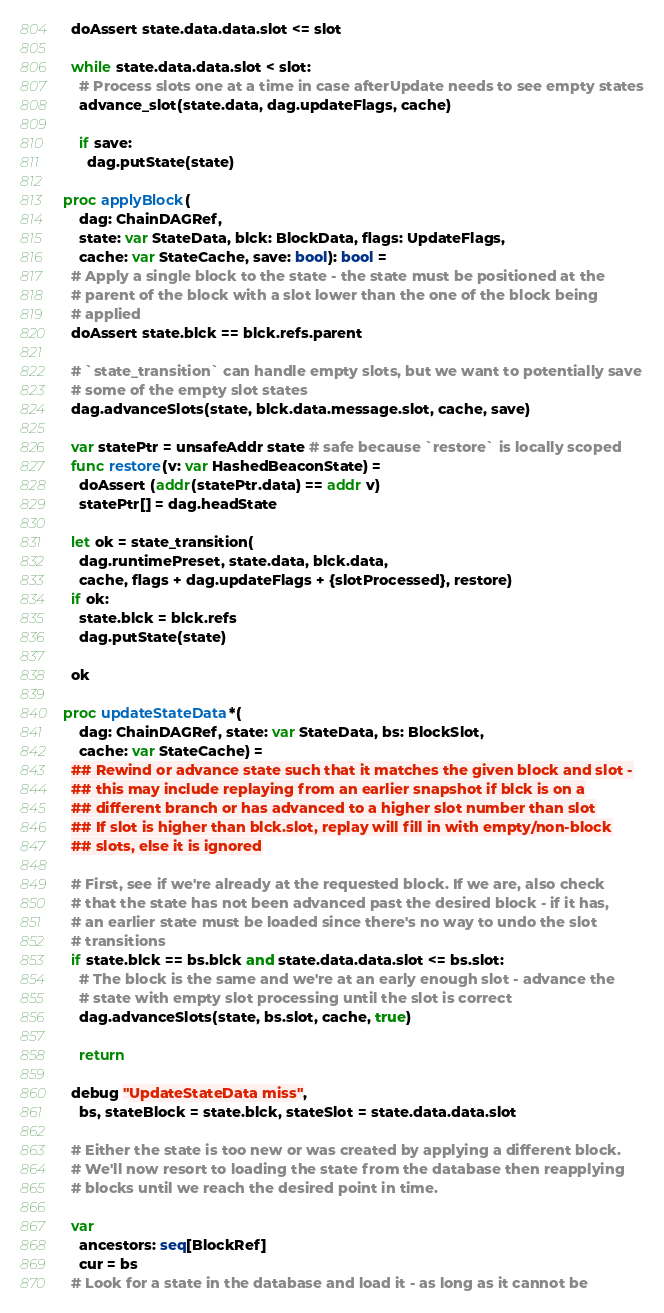<code> <loc_0><loc_0><loc_500><loc_500><_Nim_>  doAssert state.data.data.slot <= slot

  while state.data.data.slot < slot:
    # Process slots one at a time in case afterUpdate needs to see empty states
    advance_slot(state.data, dag.updateFlags, cache)

    if save:
      dag.putState(state)

proc applyBlock(
    dag: ChainDAGRef,
    state: var StateData, blck: BlockData, flags: UpdateFlags,
    cache: var StateCache, save: bool): bool =
  # Apply a single block to the state - the state must be positioned at the
  # parent of the block with a slot lower than the one of the block being
  # applied
  doAssert state.blck == blck.refs.parent

  # `state_transition` can handle empty slots, but we want to potentially save
  # some of the empty slot states
  dag.advanceSlots(state, blck.data.message.slot, cache, save)

  var statePtr = unsafeAddr state # safe because `restore` is locally scoped
  func restore(v: var HashedBeaconState) =
    doAssert (addr(statePtr.data) == addr v)
    statePtr[] = dag.headState

  let ok = state_transition(
    dag.runtimePreset, state.data, blck.data,
    cache, flags + dag.updateFlags + {slotProcessed}, restore)
  if ok:
    state.blck = blck.refs
    dag.putState(state)

  ok

proc updateStateData*(
    dag: ChainDAGRef, state: var StateData, bs: BlockSlot,
    cache: var StateCache) =
  ## Rewind or advance state such that it matches the given block and slot -
  ## this may include replaying from an earlier snapshot if blck is on a
  ## different branch or has advanced to a higher slot number than slot
  ## If slot is higher than blck.slot, replay will fill in with empty/non-block
  ## slots, else it is ignored

  # First, see if we're already at the requested block. If we are, also check
  # that the state has not been advanced past the desired block - if it has,
  # an earlier state must be loaded since there's no way to undo the slot
  # transitions
  if state.blck == bs.blck and state.data.data.slot <= bs.slot:
    # The block is the same and we're at an early enough slot - advance the
    # state with empty slot processing until the slot is correct
    dag.advanceSlots(state, bs.slot, cache, true)

    return

  debug "UpdateStateData miss",
    bs, stateBlock = state.blck, stateSlot = state.data.data.slot

  # Either the state is too new or was created by applying a different block.
  # We'll now resort to loading the state from the database then reapplying
  # blocks until we reach the desired point in time.

  var
    ancestors: seq[BlockRef]
    cur = bs
  # Look for a state in the database and load it - as long as it cannot be</code> 